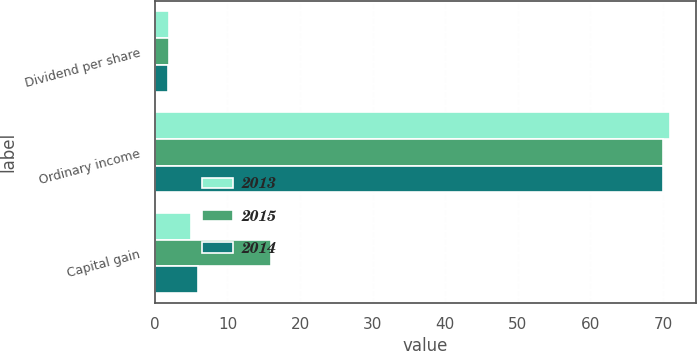Convert chart to OTSL. <chart><loc_0><loc_0><loc_500><loc_500><stacked_bar_chart><ecel><fcel>Dividend per share<fcel>Ordinary income<fcel>Capital gain<nl><fcel>2013<fcel>1.94<fcel>71<fcel>5<nl><fcel>2015<fcel>1.88<fcel>70<fcel>16<nl><fcel>2014<fcel>1.85<fcel>70<fcel>6<nl></chart> 